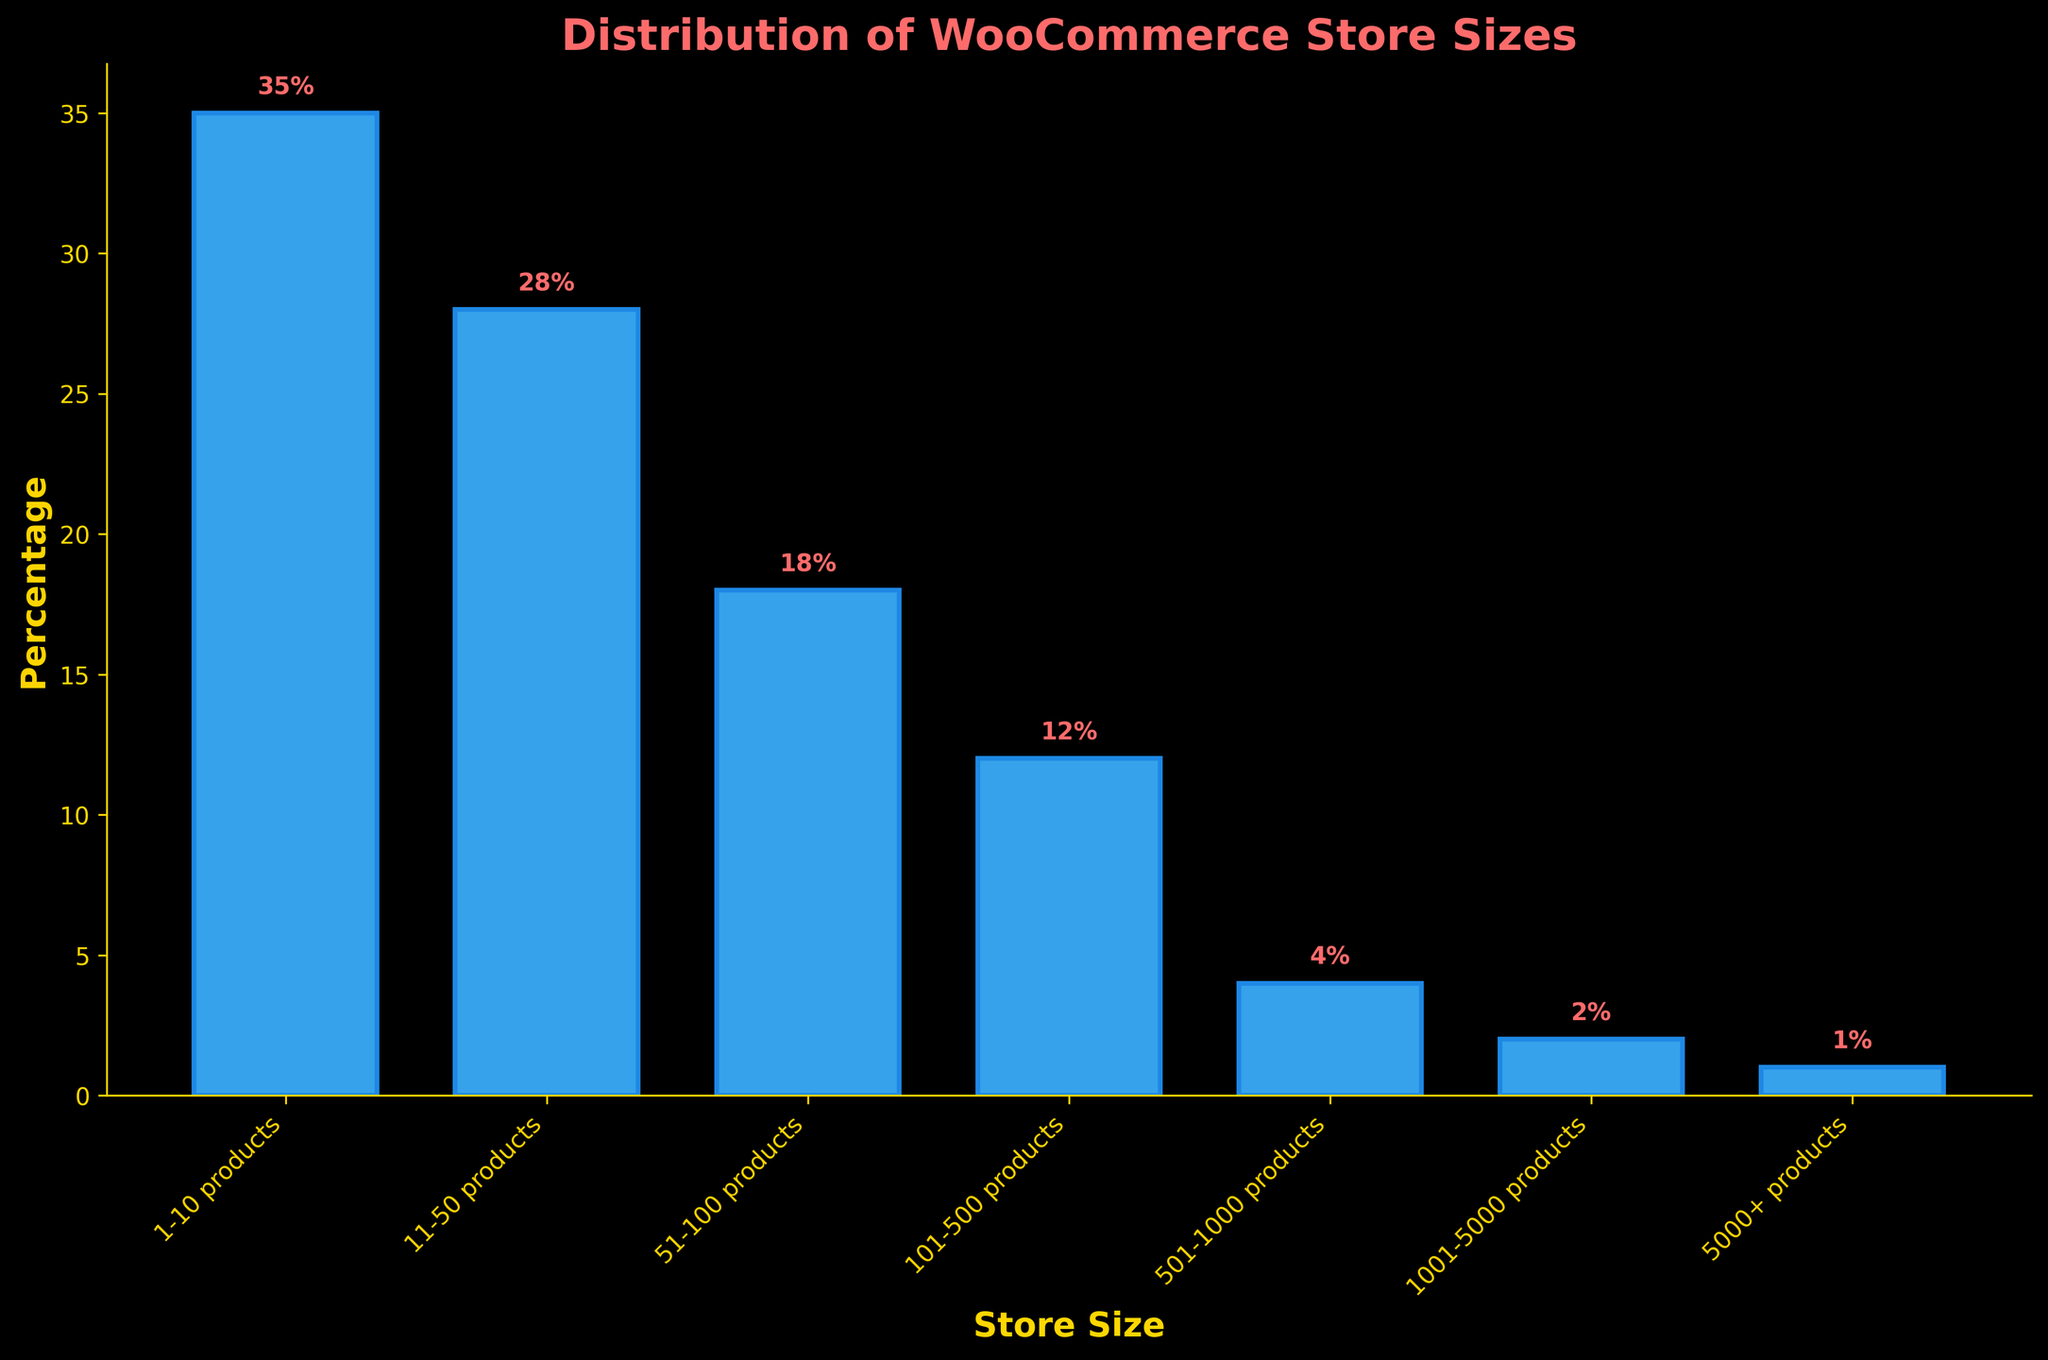What's the percentage of WooCommerce stores with 1-10 products? The bar labeled "1-10 products" has a height indicating its percentage. The value written above the bar is 35.
Answer: 35% Which store size category has the smallest percentage? The bar labeled "5000+ products" has the shortest height and the smallest percentage written above it, which is 1%.
Answer: 5000+ products How much higher is the percentage of stores with 51-100 products compared to those with 501-1000 products? The percentage of stores with 51-100 products is 18%, and the percentage with 501-1000 products is 4%. The difference is calculated as 18% - 4% = 14%.
Answer: 14% Which two store size categories have a combined percentage of over 50%? Adding the percentages of the categories: "1-10 products" (35%) and "11-50 products" (28%), yields a total of 35% + 28% = 63%, which is over 50%.
Answer: 1-10 products and 11-50 products What is the percentage difference between the categories "11-50 products" and "51-100 products"? The percentage of stores with 11-50 products is 28%, and the percentage with 51-100 products is 18%. The difference is calculated as 28% - 18% = 10%.
Answer: 10% Which store size category has a percentage twice that of the "101-500 products" category? The percentage for the "101-500 products" category is 12%. The category with twice that percentage would have 24%. None of the categories have an exact percentage of 24%, therefore the answer is none.
Answer: None What is the combined percentage for the categories of stores with more than 500 products? Adding the percentages of the categories "501-1000 products" (4%), "1001-5000 products" (2%), and "5000+ products" (1%) yields a total of 4% + 2% + 1% = 7%.
Answer: 7% What percentage of stores have between 1 and 100 products? Adding the percentages for categories "1-10 products" (35%), "11-50 products" (28%), and "51-100 products" (18%) yields a total of 35% + 28% + 18% = 81%.
Answer: 81% Which store size category represents a quarter (25%) of the total percentage? None of the categories shown have a percentage that equals 25%. The closest is "11-50 products" with 28%, but this is still not equal to 25%.
Answer: None 